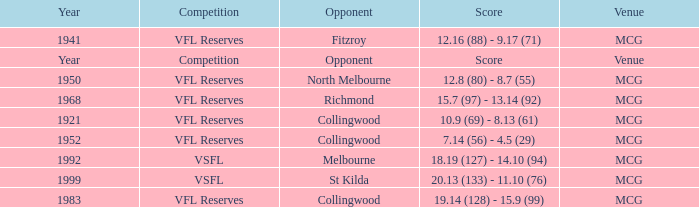At what venue did the team from Collingwood score 7.14 (56) - 4.5 (29)? MCG. Could you help me parse every detail presented in this table? {'header': ['Year', 'Competition', 'Opponent', 'Score', 'Venue'], 'rows': [['1941', 'VFL Reserves', 'Fitzroy', '12.16 (88) - 9.17 (71)', 'MCG'], ['Year', 'Competition', 'Opponent', 'Score', 'Venue'], ['1950', 'VFL Reserves', 'North Melbourne', '12.8 (80) - 8.7 (55)', 'MCG'], ['1968', 'VFL Reserves', 'Richmond', '15.7 (97) - 13.14 (92)', 'MCG'], ['1921', 'VFL Reserves', 'Collingwood', '10.9 (69) - 8.13 (61)', 'MCG'], ['1952', 'VFL Reserves', 'Collingwood', '7.14 (56) - 4.5 (29)', 'MCG'], ['1992', 'VSFL', 'Melbourne', '18.19 (127) - 14.10 (94)', 'MCG'], ['1999', 'VSFL', 'St Kilda', '20.13 (133) - 11.10 (76)', 'MCG'], ['1983', 'VFL Reserves', 'Collingwood', '19.14 (128) - 15.9 (99)', 'MCG']]} 